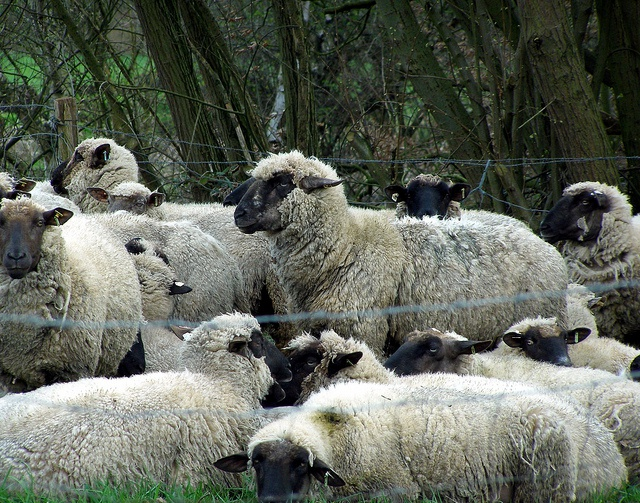Describe the objects in this image and their specific colors. I can see sheep in darkgreen, lightgray, darkgray, gray, and black tones, sheep in darkgreen, darkgray, gray, and black tones, sheep in darkgreen, darkgray, lightgray, gray, and black tones, sheep in darkgreen, gray, black, darkgray, and ivory tones, and sheep in darkgreen, lightgray, black, darkgray, and gray tones in this image. 